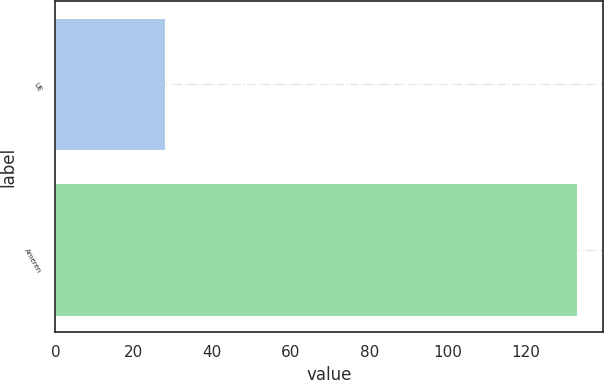Convert chart. <chart><loc_0><loc_0><loc_500><loc_500><bar_chart><fcel>UE<fcel>Ameren<nl><fcel>28<fcel>133<nl></chart> 